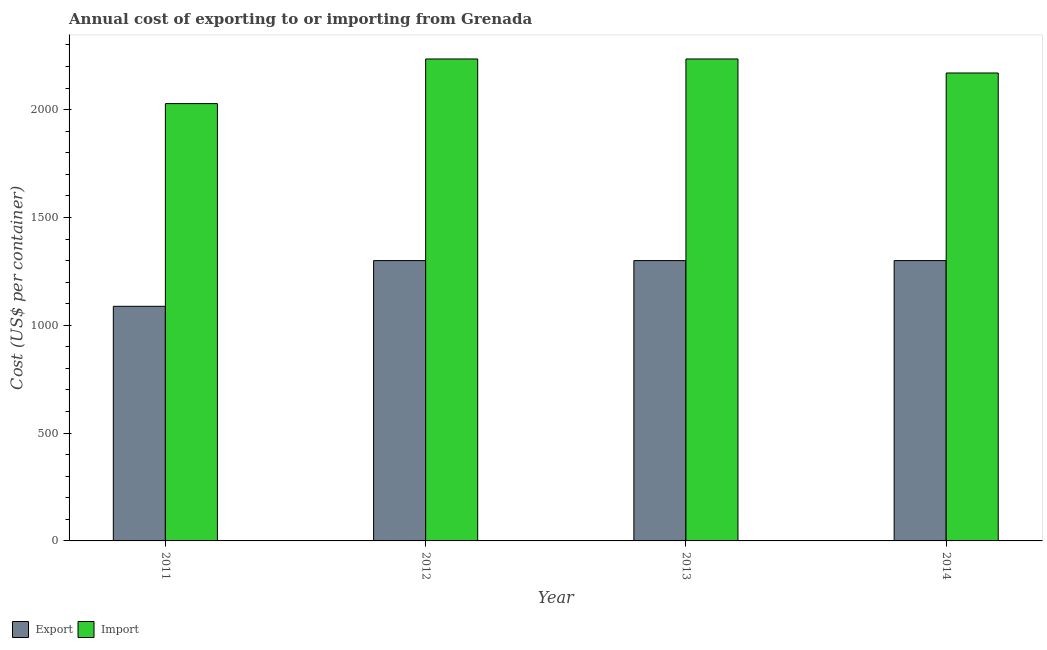How many different coloured bars are there?
Provide a short and direct response. 2. How many groups of bars are there?
Keep it short and to the point. 4. Are the number of bars per tick equal to the number of legend labels?
Your answer should be very brief. Yes. How many bars are there on the 2nd tick from the left?
Make the answer very short. 2. In how many cases, is the number of bars for a given year not equal to the number of legend labels?
Offer a very short reply. 0. What is the import cost in 2013?
Provide a short and direct response. 2235. Across all years, what is the maximum export cost?
Offer a terse response. 1300. Across all years, what is the minimum export cost?
Your response must be concise. 1088. In which year was the export cost maximum?
Provide a succinct answer. 2012. What is the total import cost in the graph?
Offer a very short reply. 8668. What is the difference between the import cost in 2012 and that in 2014?
Offer a very short reply. 65. What is the difference between the export cost in 2012 and the import cost in 2011?
Your answer should be very brief. 212. What is the average export cost per year?
Your response must be concise. 1247. In the year 2012, what is the difference between the import cost and export cost?
Ensure brevity in your answer.  0. In how many years, is the export cost greater than 1800 US$?
Offer a very short reply. 0. Is the import cost in 2011 less than that in 2013?
Offer a terse response. Yes. What is the difference between the highest and the second highest export cost?
Offer a very short reply. 0. What is the difference between the highest and the lowest import cost?
Make the answer very short. 207. In how many years, is the import cost greater than the average import cost taken over all years?
Provide a succinct answer. 3. What does the 1st bar from the left in 2013 represents?
Provide a short and direct response. Export. What does the 2nd bar from the right in 2012 represents?
Your answer should be compact. Export. How many bars are there?
Provide a succinct answer. 8. Are all the bars in the graph horizontal?
Your answer should be compact. No. Are the values on the major ticks of Y-axis written in scientific E-notation?
Offer a very short reply. No. Does the graph contain grids?
Keep it short and to the point. No. Where does the legend appear in the graph?
Offer a very short reply. Bottom left. How many legend labels are there?
Offer a very short reply. 2. How are the legend labels stacked?
Offer a terse response. Horizontal. What is the title of the graph?
Provide a succinct answer. Annual cost of exporting to or importing from Grenada. Does "Urban" appear as one of the legend labels in the graph?
Ensure brevity in your answer.  No. What is the label or title of the X-axis?
Your answer should be very brief. Year. What is the label or title of the Y-axis?
Your response must be concise. Cost (US$ per container). What is the Cost (US$ per container) in Export in 2011?
Provide a short and direct response. 1088. What is the Cost (US$ per container) of Import in 2011?
Provide a short and direct response. 2028. What is the Cost (US$ per container) in Export in 2012?
Your response must be concise. 1300. What is the Cost (US$ per container) of Import in 2012?
Give a very brief answer. 2235. What is the Cost (US$ per container) of Export in 2013?
Provide a short and direct response. 1300. What is the Cost (US$ per container) in Import in 2013?
Offer a terse response. 2235. What is the Cost (US$ per container) of Export in 2014?
Offer a very short reply. 1300. What is the Cost (US$ per container) of Import in 2014?
Give a very brief answer. 2170. Across all years, what is the maximum Cost (US$ per container) of Export?
Make the answer very short. 1300. Across all years, what is the maximum Cost (US$ per container) of Import?
Make the answer very short. 2235. Across all years, what is the minimum Cost (US$ per container) in Export?
Ensure brevity in your answer.  1088. Across all years, what is the minimum Cost (US$ per container) in Import?
Give a very brief answer. 2028. What is the total Cost (US$ per container) of Export in the graph?
Your answer should be compact. 4988. What is the total Cost (US$ per container) in Import in the graph?
Ensure brevity in your answer.  8668. What is the difference between the Cost (US$ per container) in Export in 2011 and that in 2012?
Provide a succinct answer. -212. What is the difference between the Cost (US$ per container) in Import in 2011 and that in 2012?
Offer a very short reply. -207. What is the difference between the Cost (US$ per container) in Export in 2011 and that in 2013?
Keep it short and to the point. -212. What is the difference between the Cost (US$ per container) in Import in 2011 and that in 2013?
Ensure brevity in your answer.  -207. What is the difference between the Cost (US$ per container) in Export in 2011 and that in 2014?
Your answer should be very brief. -212. What is the difference between the Cost (US$ per container) of Import in 2011 and that in 2014?
Give a very brief answer. -142. What is the difference between the Cost (US$ per container) in Import in 2012 and that in 2013?
Your response must be concise. 0. What is the difference between the Cost (US$ per container) in Import in 2012 and that in 2014?
Give a very brief answer. 65. What is the difference between the Cost (US$ per container) of Import in 2013 and that in 2014?
Offer a very short reply. 65. What is the difference between the Cost (US$ per container) in Export in 2011 and the Cost (US$ per container) in Import in 2012?
Provide a short and direct response. -1147. What is the difference between the Cost (US$ per container) of Export in 2011 and the Cost (US$ per container) of Import in 2013?
Offer a very short reply. -1147. What is the difference between the Cost (US$ per container) of Export in 2011 and the Cost (US$ per container) of Import in 2014?
Your answer should be compact. -1082. What is the difference between the Cost (US$ per container) of Export in 2012 and the Cost (US$ per container) of Import in 2013?
Give a very brief answer. -935. What is the difference between the Cost (US$ per container) of Export in 2012 and the Cost (US$ per container) of Import in 2014?
Ensure brevity in your answer.  -870. What is the difference between the Cost (US$ per container) in Export in 2013 and the Cost (US$ per container) in Import in 2014?
Your response must be concise. -870. What is the average Cost (US$ per container) of Export per year?
Provide a succinct answer. 1247. What is the average Cost (US$ per container) of Import per year?
Ensure brevity in your answer.  2167. In the year 2011, what is the difference between the Cost (US$ per container) in Export and Cost (US$ per container) in Import?
Offer a terse response. -940. In the year 2012, what is the difference between the Cost (US$ per container) in Export and Cost (US$ per container) in Import?
Keep it short and to the point. -935. In the year 2013, what is the difference between the Cost (US$ per container) of Export and Cost (US$ per container) of Import?
Provide a succinct answer. -935. In the year 2014, what is the difference between the Cost (US$ per container) in Export and Cost (US$ per container) in Import?
Offer a very short reply. -870. What is the ratio of the Cost (US$ per container) of Export in 2011 to that in 2012?
Offer a very short reply. 0.84. What is the ratio of the Cost (US$ per container) of Import in 2011 to that in 2012?
Your answer should be very brief. 0.91. What is the ratio of the Cost (US$ per container) in Export in 2011 to that in 2013?
Keep it short and to the point. 0.84. What is the ratio of the Cost (US$ per container) of Import in 2011 to that in 2013?
Your answer should be very brief. 0.91. What is the ratio of the Cost (US$ per container) of Export in 2011 to that in 2014?
Keep it short and to the point. 0.84. What is the ratio of the Cost (US$ per container) of Import in 2011 to that in 2014?
Give a very brief answer. 0.93. What is the ratio of the Cost (US$ per container) of Export in 2012 to that in 2013?
Give a very brief answer. 1. What is the ratio of the Cost (US$ per container) of Import in 2012 to that in 2013?
Provide a short and direct response. 1. What is the ratio of the Cost (US$ per container) in Export in 2012 to that in 2014?
Offer a very short reply. 1. What is the ratio of the Cost (US$ per container) in Import in 2012 to that in 2014?
Provide a succinct answer. 1.03. What is the ratio of the Cost (US$ per container) of Import in 2013 to that in 2014?
Ensure brevity in your answer.  1.03. What is the difference between the highest and the second highest Cost (US$ per container) of Import?
Provide a short and direct response. 0. What is the difference between the highest and the lowest Cost (US$ per container) in Export?
Provide a succinct answer. 212. What is the difference between the highest and the lowest Cost (US$ per container) in Import?
Ensure brevity in your answer.  207. 